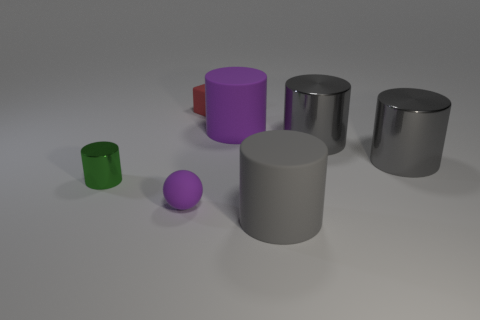What is the material of the large cylinder that is the same color as the sphere?
Give a very brief answer. Rubber. What is the color of the tiny rubber object behind the purple object to the right of the object behind the purple rubber cylinder?
Ensure brevity in your answer.  Red. Are there any other things that are the same size as the green thing?
Give a very brief answer. Yes. Do the matte block and the cylinder to the left of the large purple rubber thing have the same color?
Your answer should be very brief. No. What color is the tiny sphere?
Your response must be concise. Purple. There is a purple thing that is on the left side of the large matte thing that is behind the shiny thing on the left side of the tiny purple matte thing; what is its shape?
Offer a very short reply. Sphere. What number of other things are the same color as the ball?
Make the answer very short. 1. Are there more tiny things right of the green shiny thing than tiny rubber balls right of the red thing?
Make the answer very short. Yes. Are there any purple things behind the purple ball?
Keep it short and to the point. Yes. The thing that is both in front of the tiny green shiny cylinder and left of the red rubber thing is made of what material?
Provide a short and direct response. Rubber. 